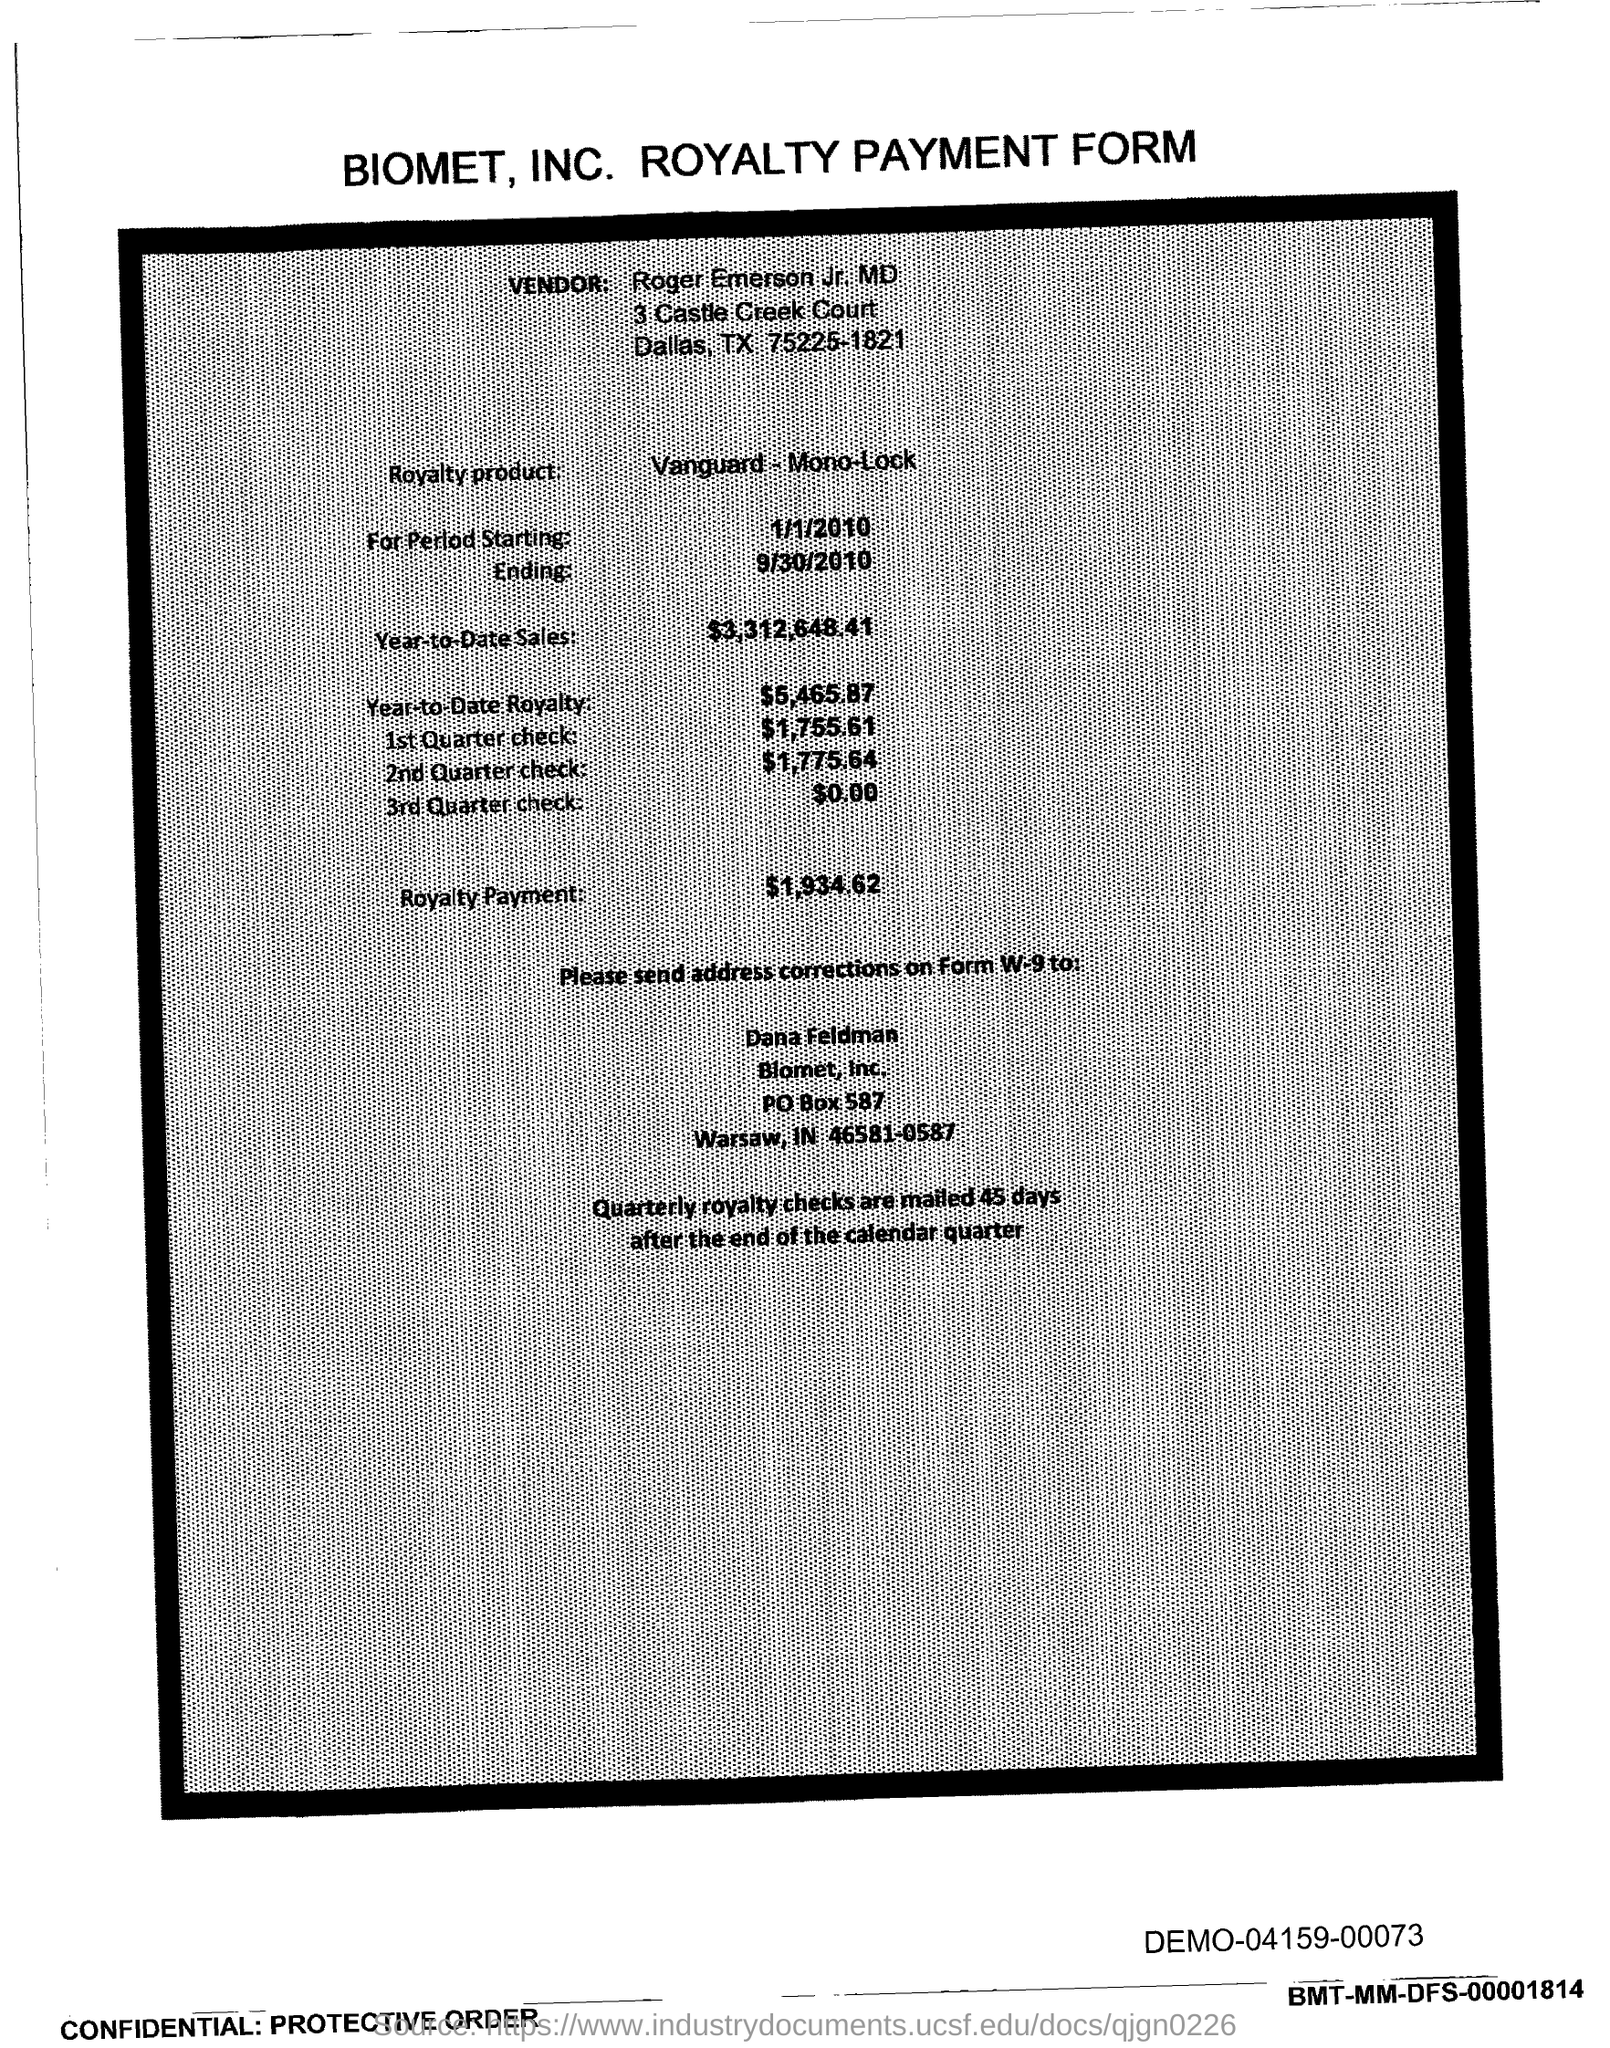Outline some significant characteristics in this image. The amount mentioned in the form for the 2nd Quarter check is $1,775.64. The year-to-date royalty for the product is 5,465.87. The royalty payment for the product mentioned in the form is $1,934.62. This royalty payment form belongs to Biomet, Inc. The quartely royalty checks are mailed 45 days after the end of the calendar quarter. 